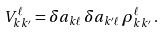Convert formula to latex. <formula><loc_0><loc_0><loc_500><loc_500>V ^ { \ell } _ { k k ^ { \prime } } = \delta a _ { k \ell } \, \delta a _ { k ^ { \prime } \ell } \, \rho ^ { \ell } _ { k k ^ { \prime } } \, .</formula> 